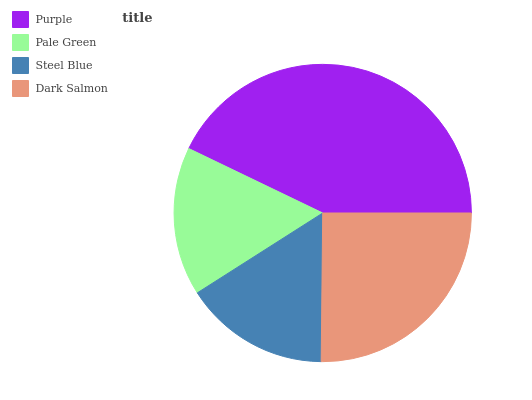Is Steel Blue the minimum?
Answer yes or no. Yes. Is Purple the maximum?
Answer yes or no. Yes. Is Pale Green the minimum?
Answer yes or no. No. Is Pale Green the maximum?
Answer yes or no. No. Is Purple greater than Pale Green?
Answer yes or no. Yes. Is Pale Green less than Purple?
Answer yes or no. Yes. Is Pale Green greater than Purple?
Answer yes or no. No. Is Purple less than Pale Green?
Answer yes or no. No. Is Dark Salmon the high median?
Answer yes or no. Yes. Is Pale Green the low median?
Answer yes or no. Yes. Is Pale Green the high median?
Answer yes or no. No. Is Purple the low median?
Answer yes or no. No. 